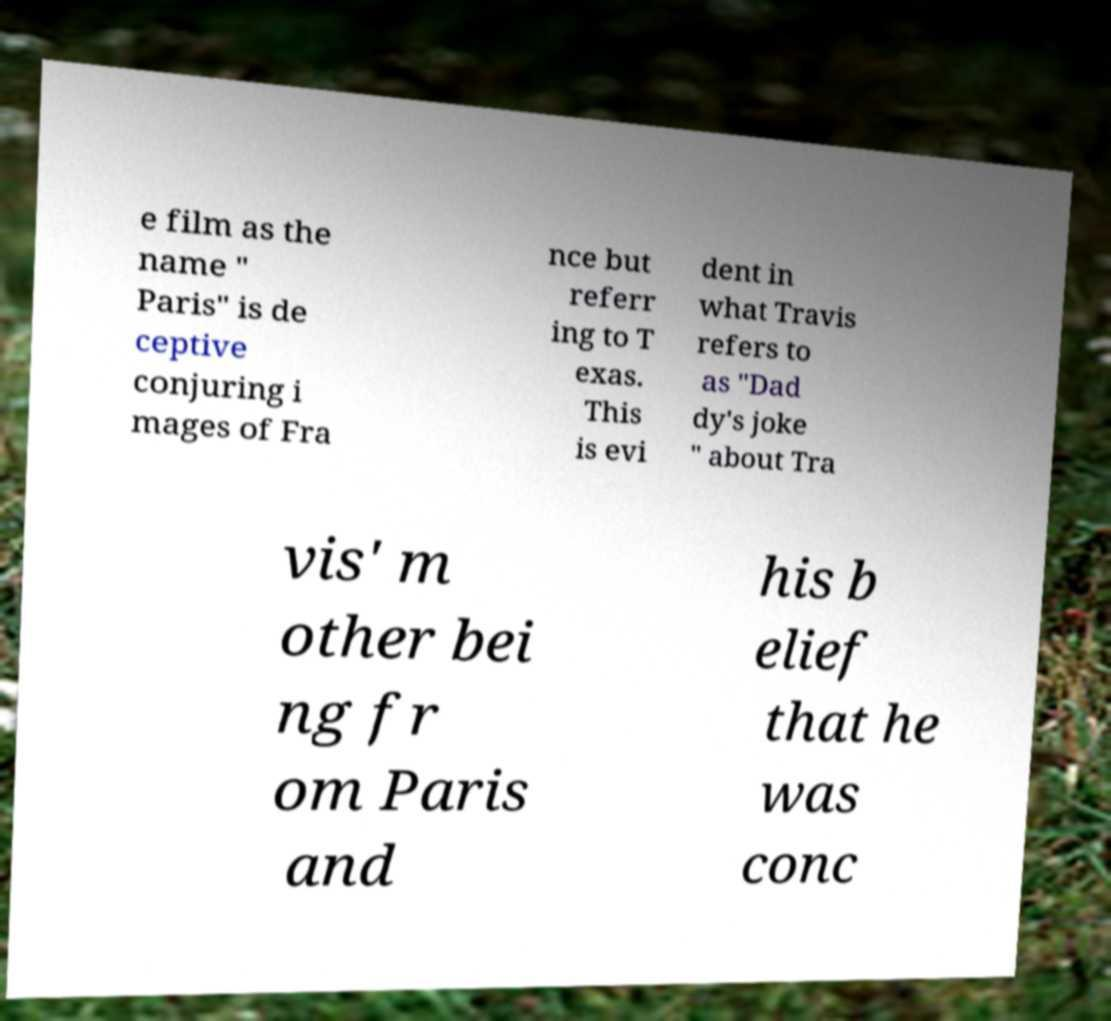Could you assist in decoding the text presented in this image and type it out clearly? e film as the name " Paris" is de ceptive conjuring i mages of Fra nce but referr ing to T exas. This is evi dent in what Travis refers to as "Dad dy's joke " about Tra vis' m other bei ng fr om Paris and his b elief that he was conc 